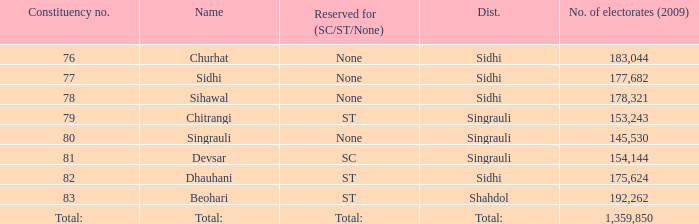What is Beohari's reserved for (SC/ST/None)? ST. 